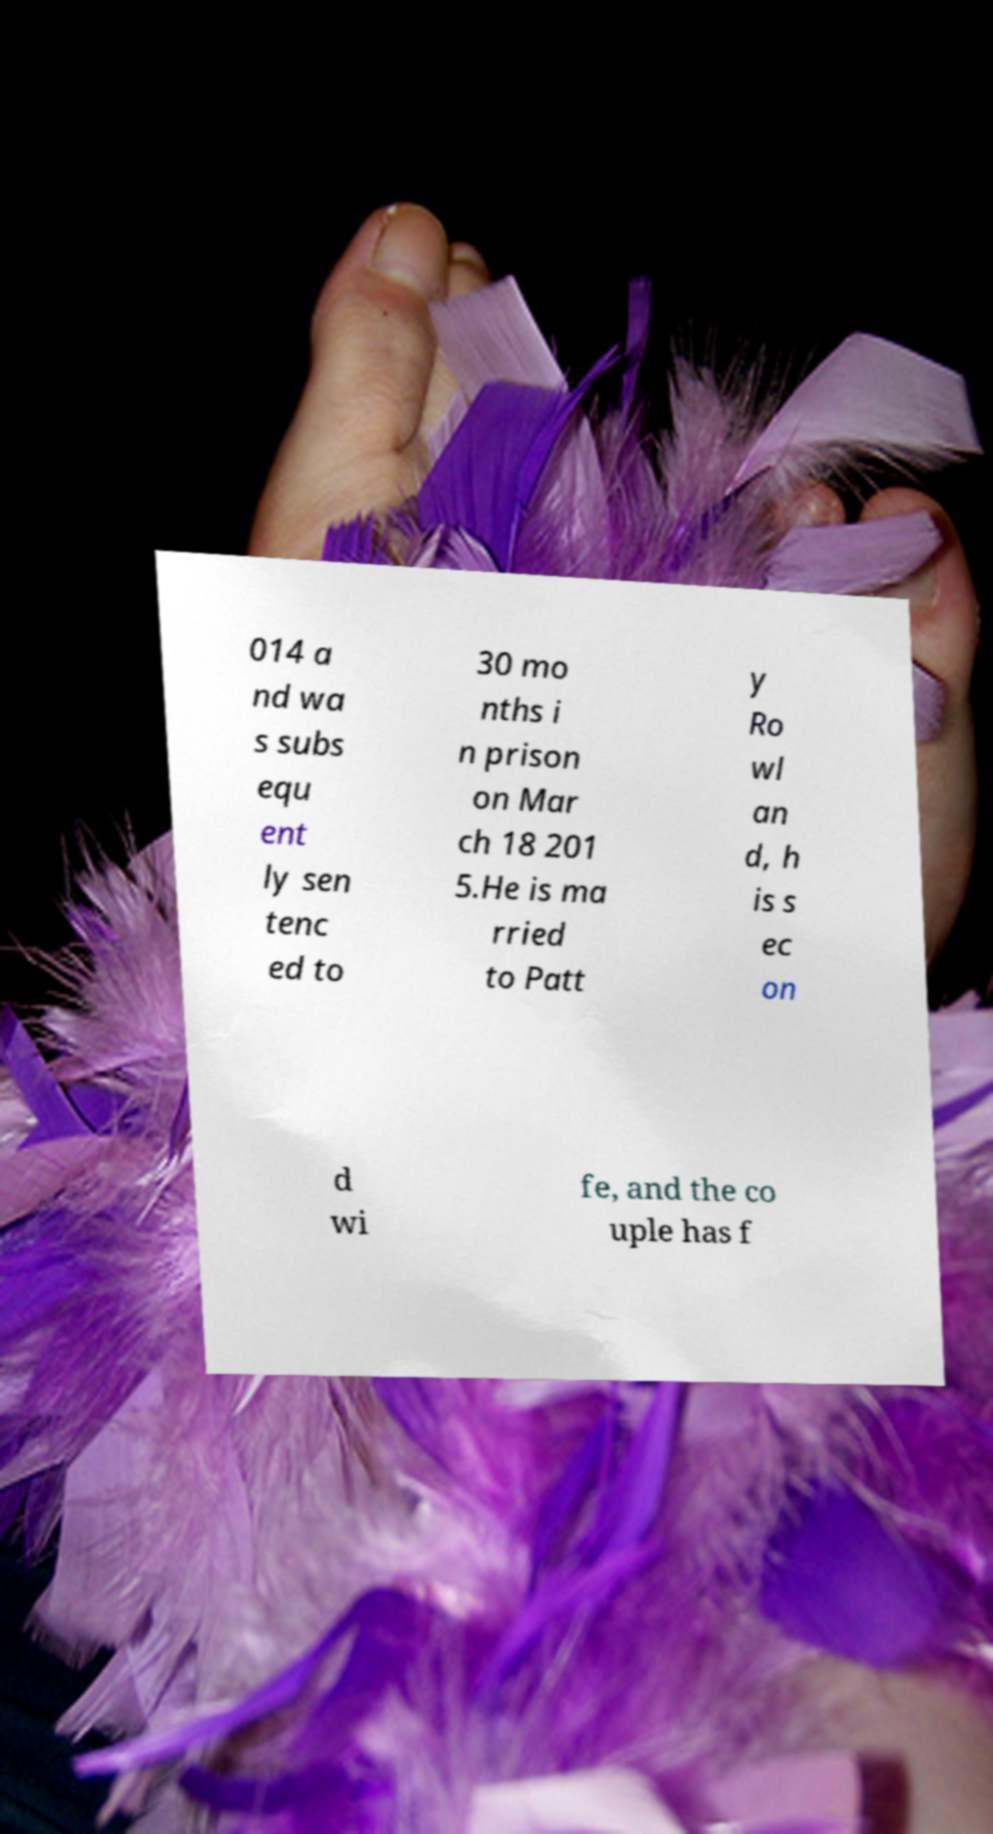Please read and relay the text visible in this image. What does it say? 014 a nd wa s subs equ ent ly sen tenc ed to 30 mo nths i n prison on Mar ch 18 201 5.He is ma rried to Patt y Ro wl an d, h is s ec on d wi fe, and the co uple has f 